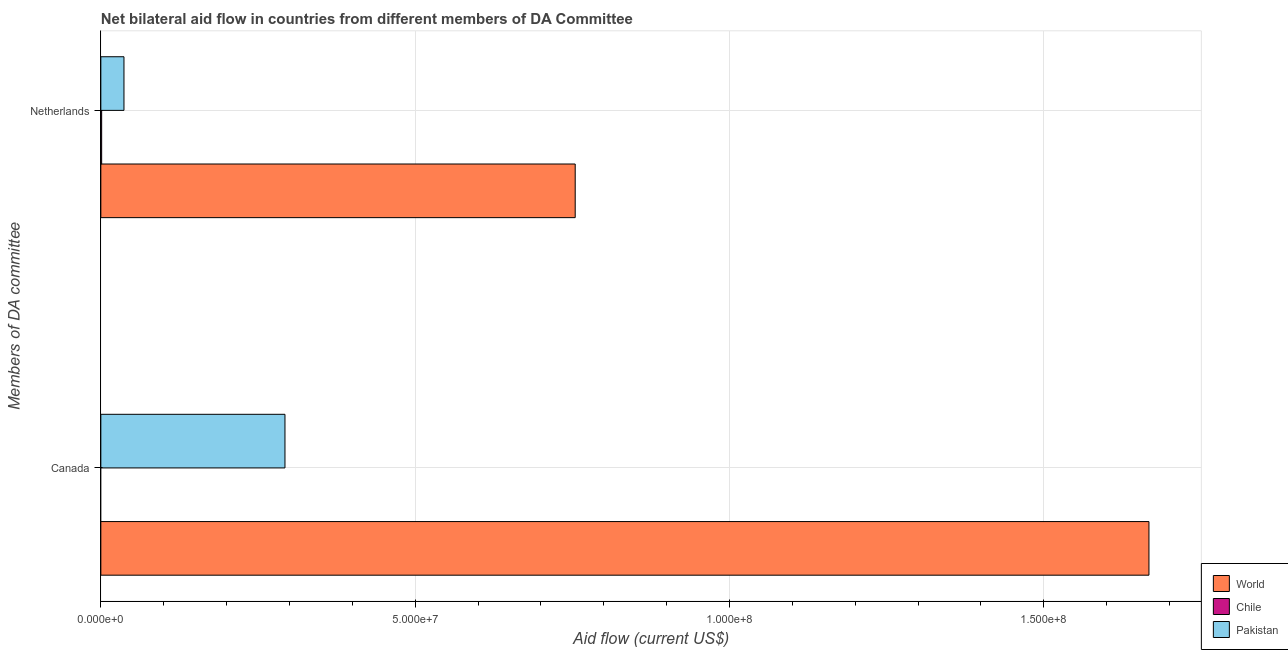Are the number of bars per tick equal to the number of legend labels?
Ensure brevity in your answer.  No. What is the label of the 1st group of bars from the top?
Your answer should be very brief. Netherlands. What is the amount of aid given by netherlands in World?
Offer a terse response. 7.55e+07. Across all countries, what is the maximum amount of aid given by canada?
Your response must be concise. 1.67e+08. What is the total amount of aid given by netherlands in the graph?
Provide a short and direct response. 7.93e+07. What is the difference between the amount of aid given by netherlands in Pakistan and that in Chile?
Offer a terse response. 3.55e+06. What is the difference between the amount of aid given by netherlands in Chile and the amount of aid given by canada in World?
Offer a terse response. -1.67e+08. What is the average amount of aid given by canada per country?
Keep it short and to the point. 6.53e+07. What is the difference between the amount of aid given by canada and amount of aid given by netherlands in Pakistan?
Ensure brevity in your answer.  2.56e+07. In how many countries, is the amount of aid given by netherlands greater than 40000000 US$?
Your answer should be very brief. 1. What is the ratio of the amount of aid given by netherlands in World to that in Pakistan?
Your answer should be very brief. 20.51. How are the legend labels stacked?
Ensure brevity in your answer.  Vertical. What is the title of the graph?
Your response must be concise. Net bilateral aid flow in countries from different members of DA Committee. Does "Suriname" appear as one of the legend labels in the graph?
Offer a very short reply. No. What is the label or title of the Y-axis?
Give a very brief answer. Members of DA committee. What is the Aid flow (current US$) in World in Canada?
Provide a short and direct response. 1.67e+08. What is the Aid flow (current US$) in Chile in Canada?
Your response must be concise. 0. What is the Aid flow (current US$) of Pakistan in Canada?
Your response must be concise. 2.93e+07. What is the Aid flow (current US$) in World in Netherlands?
Ensure brevity in your answer.  7.55e+07. What is the Aid flow (current US$) in Pakistan in Netherlands?
Provide a short and direct response. 3.68e+06. Across all Members of DA committee, what is the maximum Aid flow (current US$) of World?
Your answer should be compact. 1.67e+08. Across all Members of DA committee, what is the maximum Aid flow (current US$) in Pakistan?
Offer a very short reply. 2.93e+07. Across all Members of DA committee, what is the minimum Aid flow (current US$) of World?
Provide a succinct answer. 7.55e+07. Across all Members of DA committee, what is the minimum Aid flow (current US$) of Pakistan?
Give a very brief answer. 3.68e+06. What is the total Aid flow (current US$) in World in the graph?
Offer a very short reply. 2.42e+08. What is the total Aid flow (current US$) in Pakistan in the graph?
Provide a short and direct response. 3.30e+07. What is the difference between the Aid flow (current US$) in World in Canada and that in Netherlands?
Provide a short and direct response. 9.13e+07. What is the difference between the Aid flow (current US$) in Pakistan in Canada and that in Netherlands?
Your answer should be compact. 2.56e+07. What is the difference between the Aid flow (current US$) of World in Canada and the Aid flow (current US$) of Chile in Netherlands?
Keep it short and to the point. 1.67e+08. What is the difference between the Aid flow (current US$) of World in Canada and the Aid flow (current US$) of Pakistan in Netherlands?
Provide a succinct answer. 1.63e+08. What is the average Aid flow (current US$) in World per Members of DA committee?
Provide a short and direct response. 1.21e+08. What is the average Aid flow (current US$) of Chile per Members of DA committee?
Your response must be concise. 6.50e+04. What is the average Aid flow (current US$) of Pakistan per Members of DA committee?
Provide a short and direct response. 1.65e+07. What is the difference between the Aid flow (current US$) of World and Aid flow (current US$) of Pakistan in Canada?
Keep it short and to the point. 1.37e+08. What is the difference between the Aid flow (current US$) of World and Aid flow (current US$) of Chile in Netherlands?
Offer a terse response. 7.53e+07. What is the difference between the Aid flow (current US$) of World and Aid flow (current US$) of Pakistan in Netherlands?
Provide a short and direct response. 7.18e+07. What is the difference between the Aid flow (current US$) in Chile and Aid flow (current US$) in Pakistan in Netherlands?
Provide a short and direct response. -3.55e+06. What is the ratio of the Aid flow (current US$) of World in Canada to that in Netherlands?
Give a very brief answer. 2.21. What is the ratio of the Aid flow (current US$) in Pakistan in Canada to that in Netherlands?
Make the answer very short. 7.96. What is the difference between the highest and the second highest Aid flow (current US$) of World?
Your response must be concise. 9.13e+07. What is the difference between the highest and the second highest Aid flow (current US$) in Pakistan?
Your answer should be very brief. 2.56e+07. What is the difference between the highest and the lowest Aid flow (current US$) in World?
Your answer should be compact. 9.13e+07. What is the difference between the highest and the lowest Aid flow (current US$) in Chile?
Provide a succinct answer. 1.30e+05. What is the difference between the highest and the lowest Aid flow (current US$) in Pakistan?
Your response must be concise. 2.56e+07. 